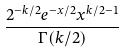<formula> <loc_0><loc_0><loc_500><loc_500>\frac { 2 ^ { - k / 2 } e ^ { - x / 2 } x ^ { k / 2 - 1 } } { \Gamma ( k / 2 ) }</formula> 